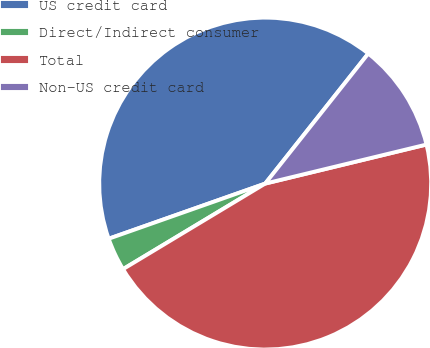Convert chart to OTSL. <chart><loc_0><loc_0><loc_500><loc_500><pie_chart><fcel>US credit card<fcel>Direct/Indirect consumer<fcel>Total<fcel>Non-US credit card<nl><fcel>41.06%<fcel>3.23%<fcel>45.16%<fcel>10.55%<nl></chart> 